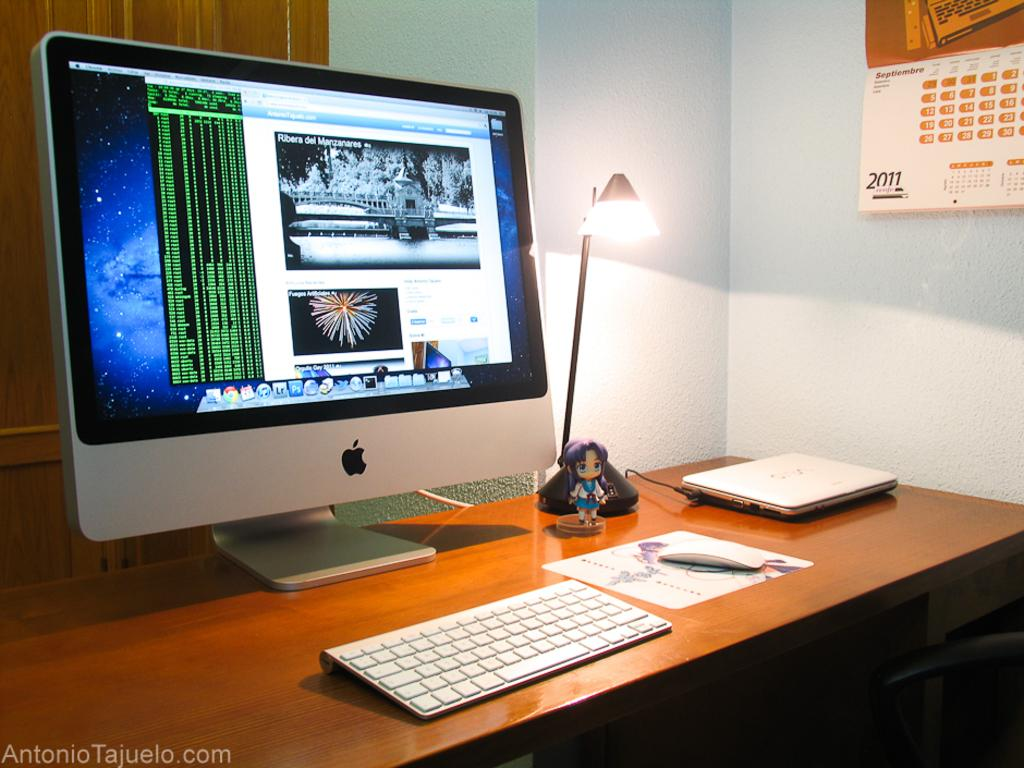What is the color of the wall in the image? The wall in the image is white. What object can be seen on the wall? There is a calendar on the wall. What furniture is present in the image? There is a table in the image. What electronic devices are on the table? There is a screen, a keyboard, and a laptop on the table. What other objects are on the table? There is a lamp and a toy on the table. What is the taste of the toy on the table? The toy on the table does not have a taste, as it is an inanimate object. 